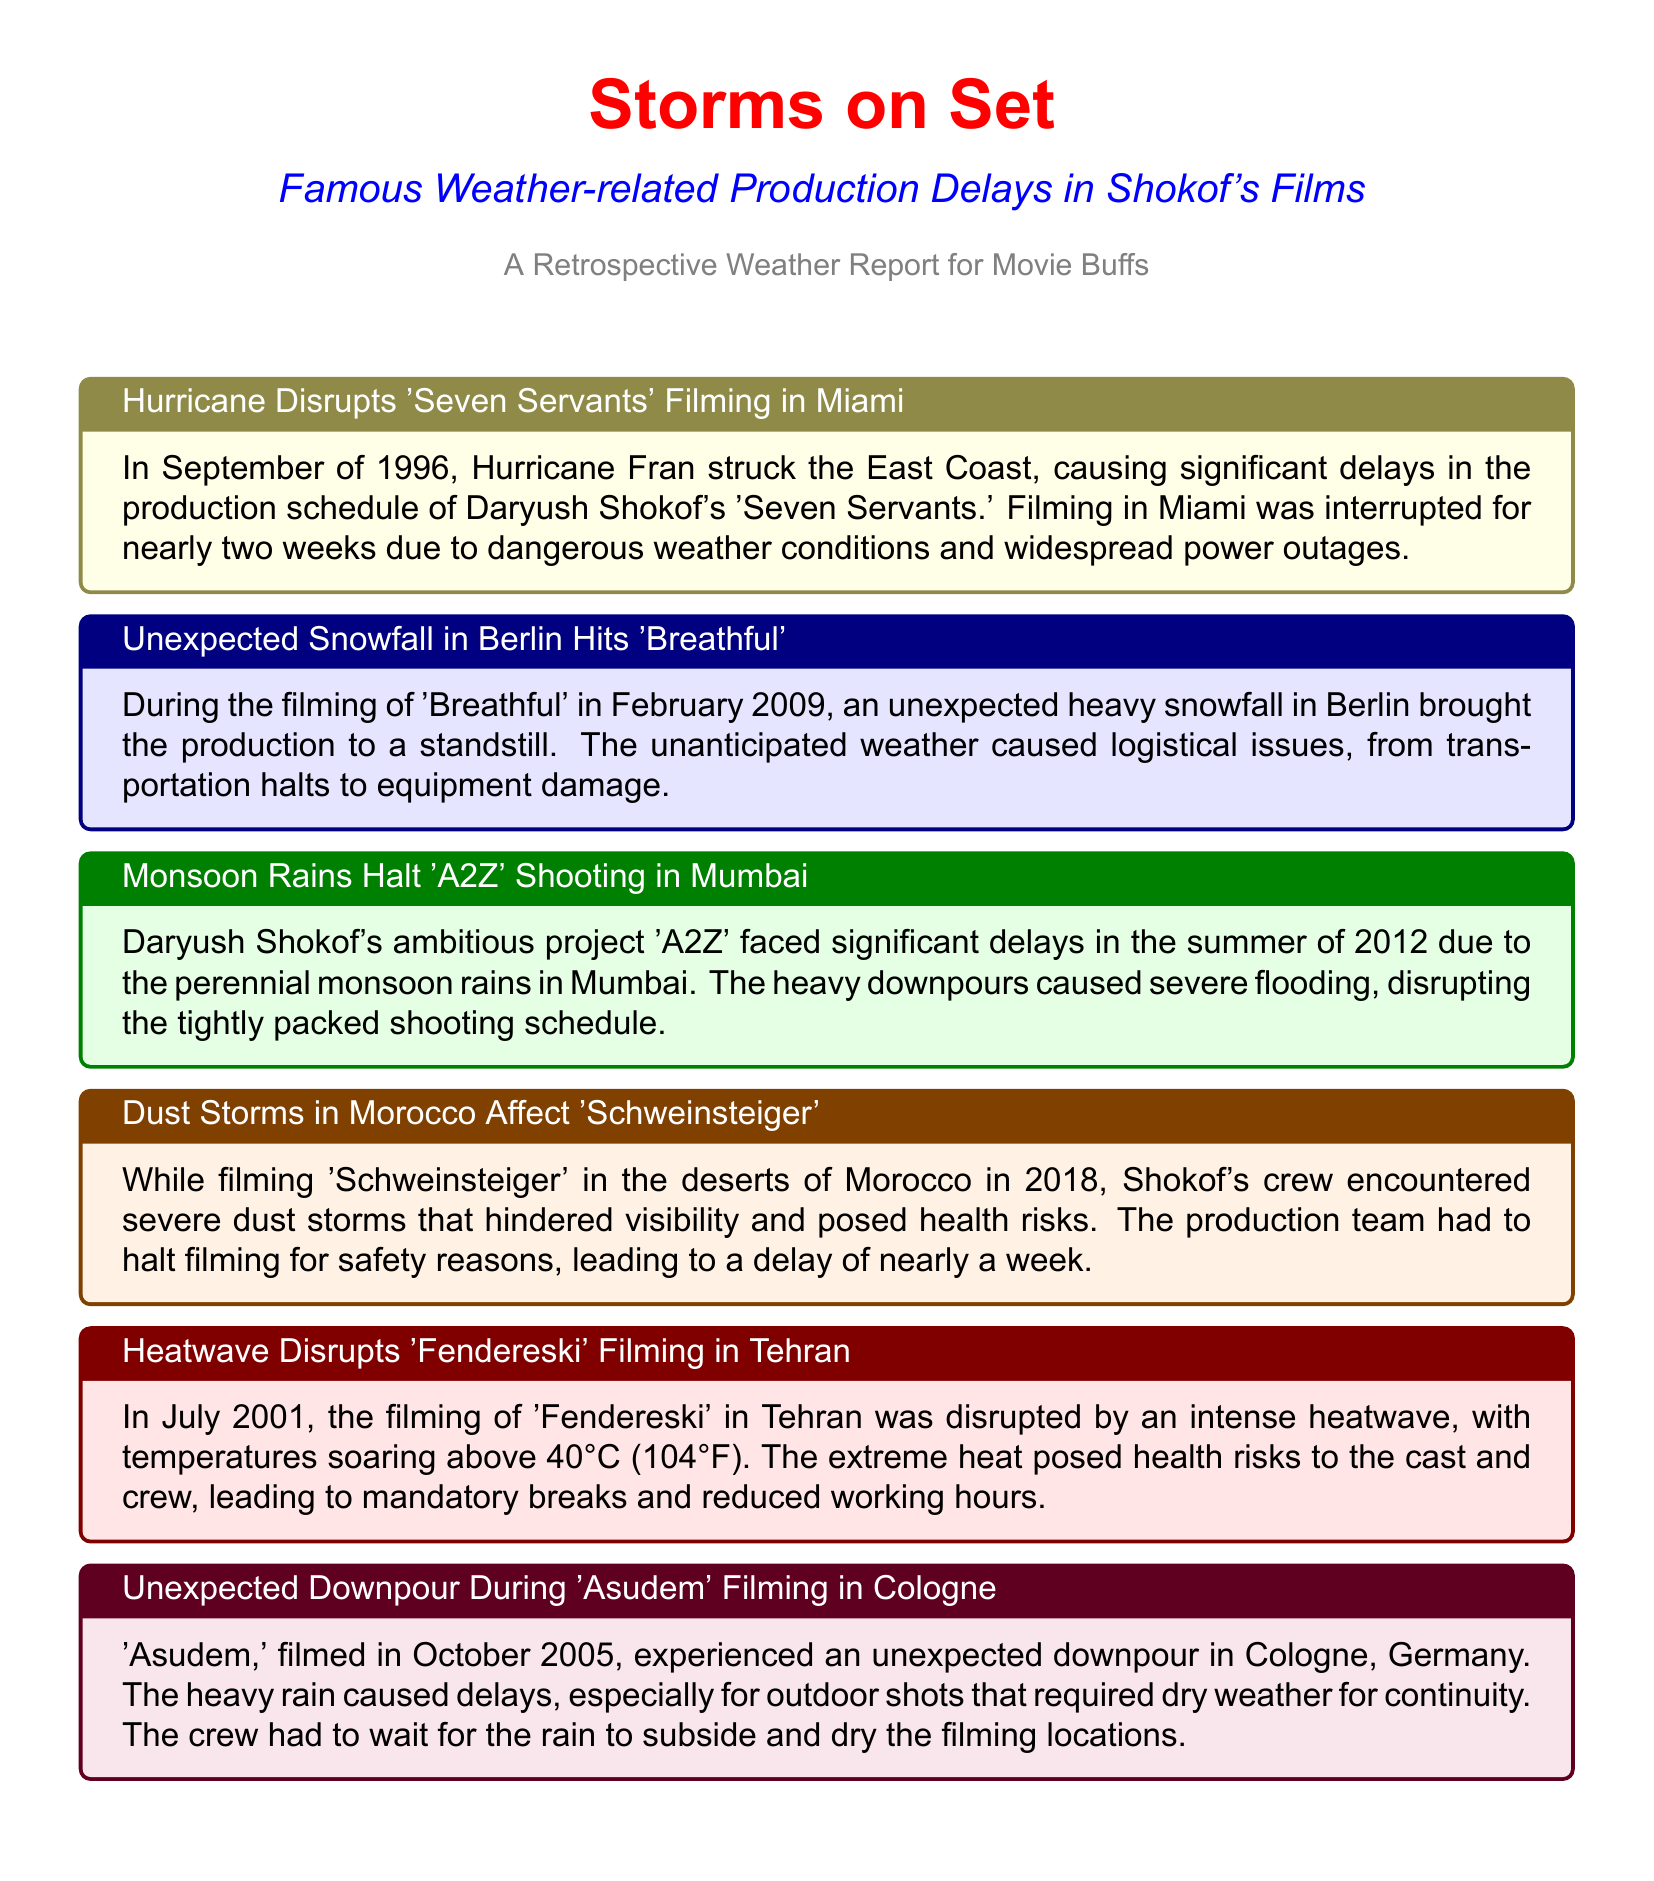What hurricane delayed 'Seven Servants' filming? Hurricane Fran caused significant delays in the production schedule of Daryush Shokof's 'Seven Servants.'
Answer: Hurricane Fran In what year did heavy snowfall affect 'Breathful'? The unexpected heavy snowfall in Berlin during the filming of 'Breathful' occurred in February 2009.
Answer: 2009 What caused delays during the filming of 'A2Z'? The perennial monsoon rains in Mumbai caused significant delays in the filming of 'A2Z' in the summer of 2012.
Answer: Monsoon rains How long was filming halted due to dust storms in 'Schweinsteiger'? Severe dust storms in Morocco during the filming of 'Schweinsteiger' led to a delay of nearly a week.
Answer: Nearly a week What extreme weather condition disrupted 'Fendereski' filming? An intense heatwave with temperatures soaring above 40°C disrupted the filming of 'Fendereski' in July 2001.
Answer: Heatwave What was the main issue during the filming of 'Asudem'? The unexpected downpour in Cologne caused delays for outdoor shots that required dry weather for continuity during the filming of 'Asudem.'
Answer: Downpour How many weeks were filming interrupted for 'Seven Servants'? Filming in Miami for 'Seven Servants' was interrupted for nearly two weeks due to Hurricane Fran.
Answer: Nearly two weeks 